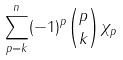Convert formula to latex. <formula><loc_0><loc_0><loc_500><loc_500>\sum _ { p = k } ^ { n } ( - 1 ) ^ { p } { p \choose k } \chi _ { p }</formula> 